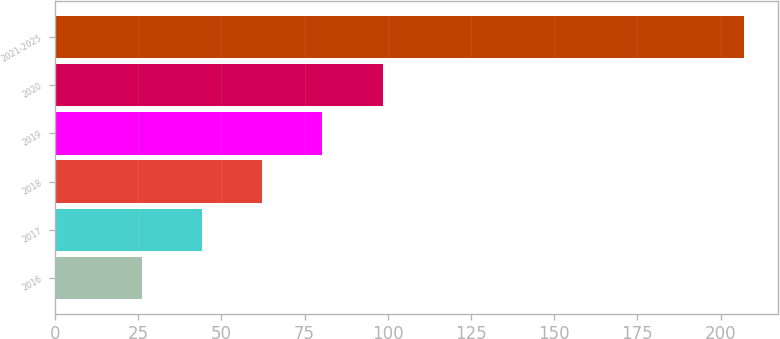Convert chart. <chart><loc_0><loc_0><loc_500><loc_500><bar_chart><fcel>2016<fcel>2017<fcel>2018<fcel>2019<fcel>2020<fcel>2021-2025<nl><fcel>26.1<fcel>44.18<fcel>62.26<fcel>80.34<fcel>98.42<fcel>206.9<nl></chart> 